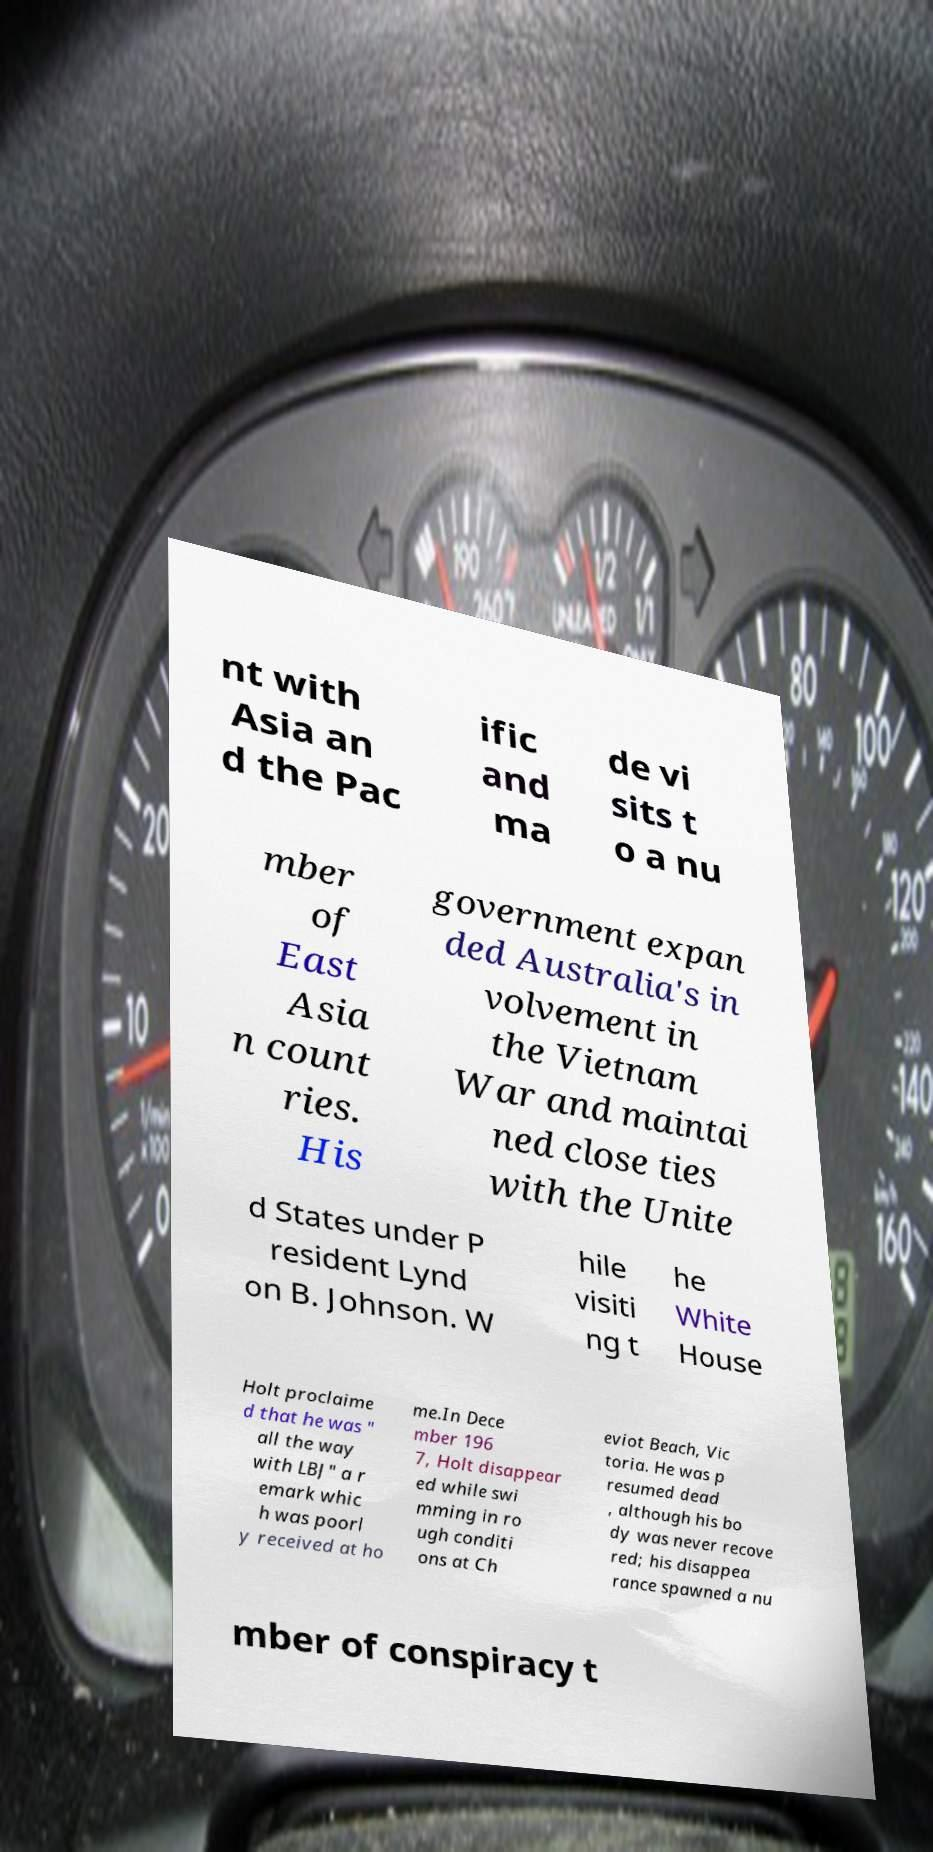Please identify and transcribe the text found in this image. nt with Asia an d the Pac ific and ma de vi sits t o a nu mber of East Asia n count ries. His government expan ded Australia's in volvement in the Vietnam War and maintai ned close ties with the Unite d States under P resident Lynd on B. Johnson. W hile visiti ng t he White House Holt proclaime d that he was " all the way with LBJ" a r emark whic h was poorl y received at ho me.In Dece mber 196 7, Holt disappear ed while swi mming in ro ugh conditi ons at Ch eviot Beach, Vic toria. He was p resumed dead , although his bo dy was never recove red; his disappea rance spawned a nu mber of conspiracy t 